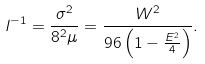<formula> <loc_0><loc_0><loc_500><loc_500>l ^ { - 1 } = \frac { \sigma ^ { 2 } } { 8 ^ { 2 } \mu } = \frac { W ^ { 2 } } { 9 6 \left ( 1 - \frac { E ^ { 2 } } 4 \right ) } .</formula> 